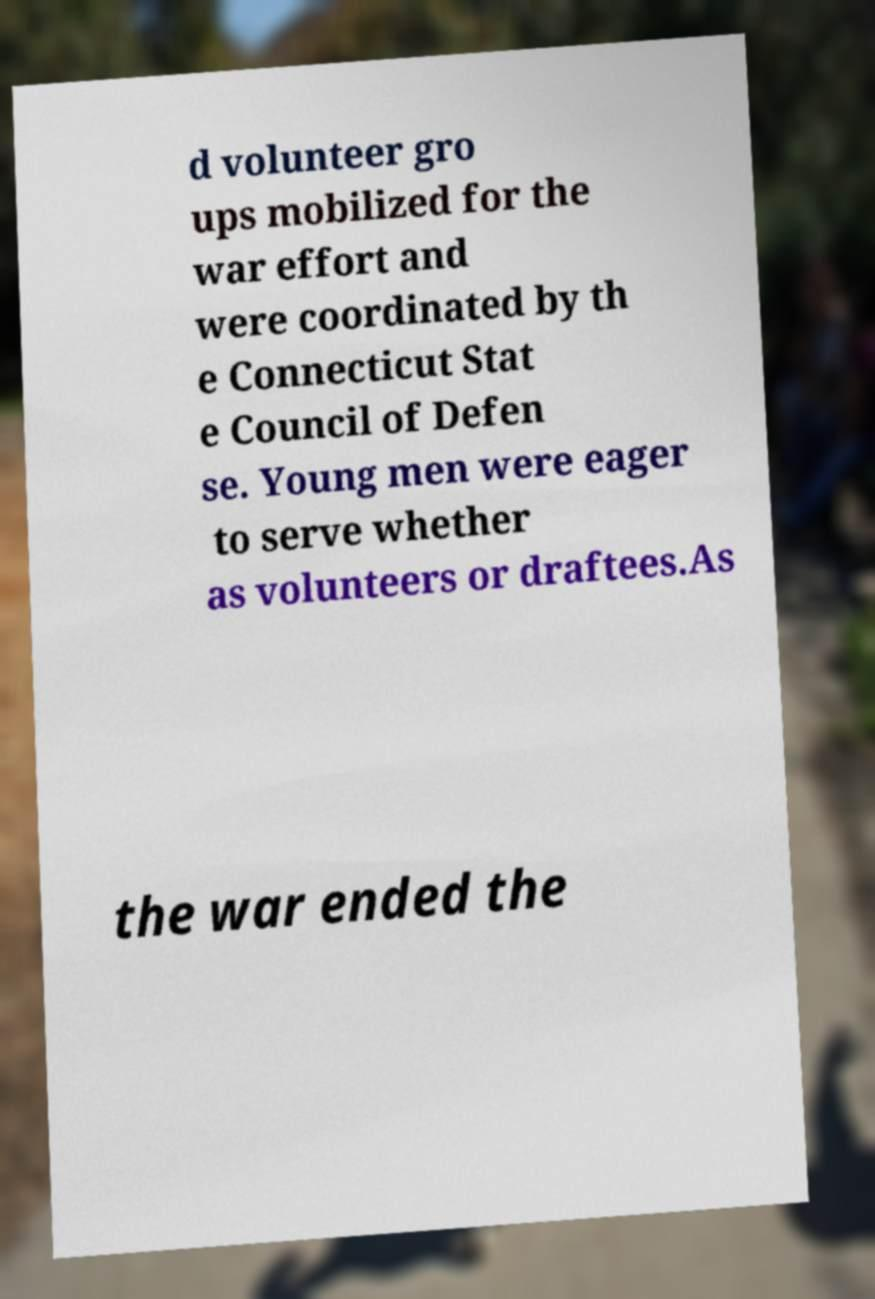Could you assist in decoding the text presented in this image and type it out clearly? d volunteer gro ups mobilized for the war effort and were coordinated by th e Connecticut Stat e Council of Defen se. Young men were eager to serve whether as volunteers or draftees.As the war ended the 